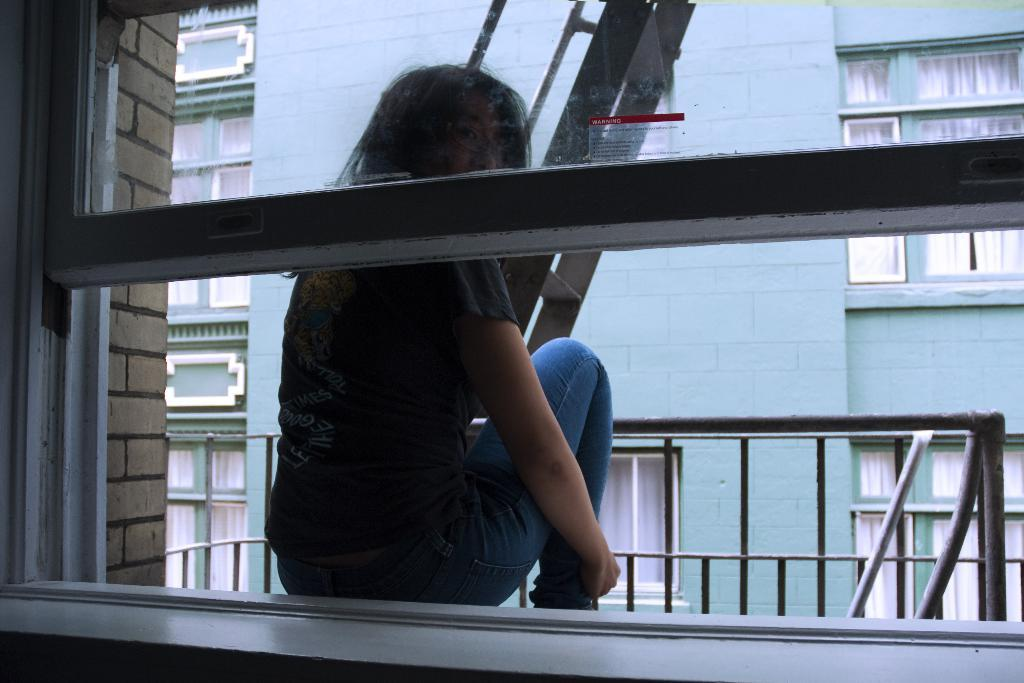What is the person in the image doing? The person is sitting behind a window. What can be seen in front of the person? There is a staircase in front of the person. What is visible in the background of the image? There are buildings in the background of the image. What type of flesh can be seen on the person's face in the image? There is no indication of the person's flesh or face in the image, as only their silhouette is visible behind the window. 